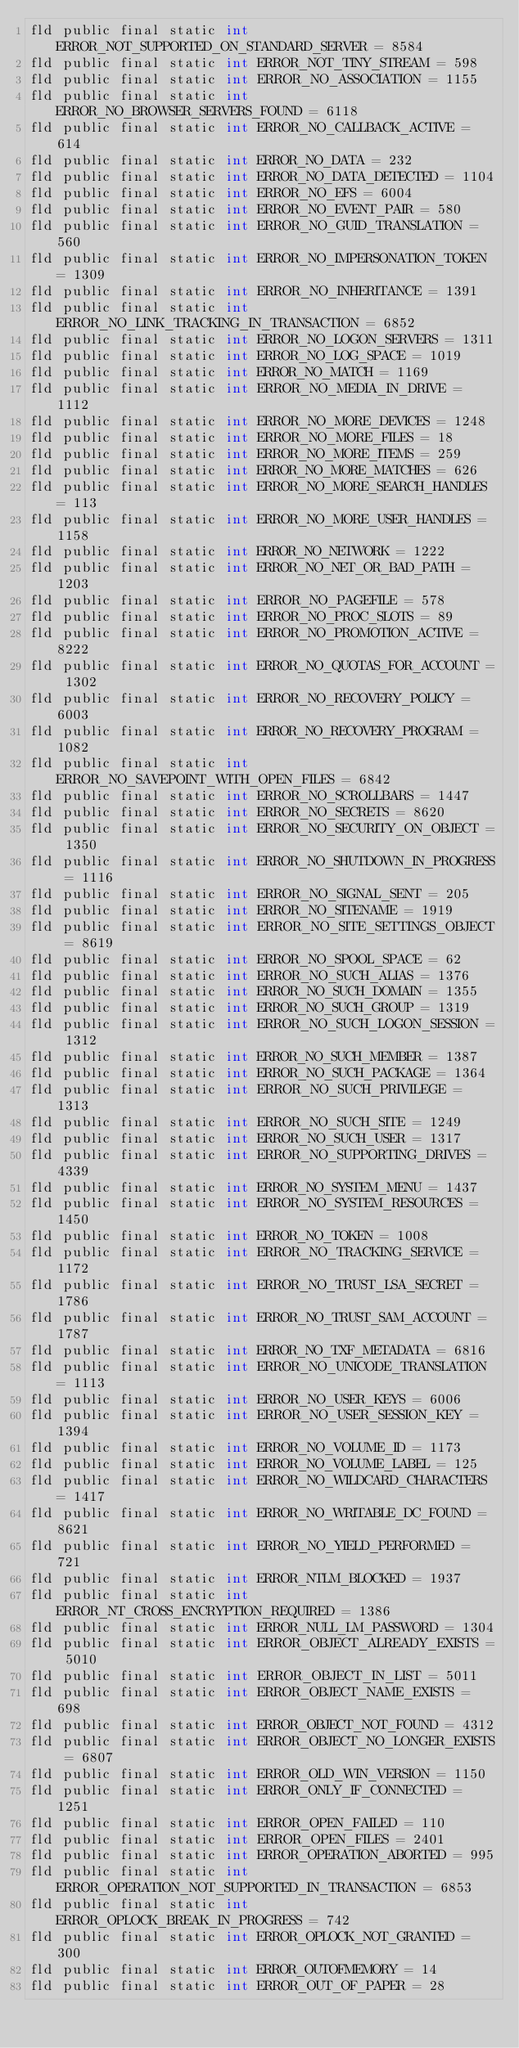Convert code to text. <code><loc_0><loc_0><loc_500><loc_500><_SML_>fld public final static int ERROR_NOT_SUPPORTED_ON_STANDARD_SERVER = 8584
fld public final static int ERROR_NOT_TINY_STREAM = 598
fld public final static int ERROR_NO_ASSOCIATION = 1155
fld public final static int ERROR_NO_BROWSER_SERVERS_FOUND = 6118
fld public final static int ERROR_NO_CALLBACK_ACTIVE = 614
fld public final static int ERROR_NO_DATA = 232
fld public final static int ERROR_NO_DATA_DETECTED = 1104
fld public final static int ERROR_NO_EFS = 6004
fld public final static int ERROR_NO_EVENT_PAIR = 580
fld public final static int ERROR_NO_GUID_TRANSLATION = 560
fld public final static int ERROR_NO_IMPERSONATION_TOKEN = 1309
fld public final static int ERROR_NO_INHERITANCE = 1391
fld public final static int ERROR_NO_LINK_TRACKING_IN_TRANSACTION = 6852
fld public final static int ERROR_NO_LOGON_SERVERS = 1311
fld public final static int ERROR_NO_LOG_SPACE = 1019
fld public final static int ERROR_NO_MATCH = 1169
fld public final static int ERROR_NO_MEDIA_IN_DRIVE = 1112
fld public final static int ERROR_NO_MORE_DEVICES = 1248
fld public final static int ERROR_NO_MORE_FILES = 18
fld public final static int ERROR_NO_MORE_ITEMS = 259
fld public final static int ERROR_NO_MORE_MATCHES = 626
fld public final static int ERROR_NO_MORE_SEARCH_HANDLES = 113
fld public final static int ERROR_NO_MORE_USER_HANDLES = 1158
fld public final static int ERROR_NO_NETWORK = 1222
fld public final static int ERROR_NO_NET_OR_BAD_PATH = 1203
fld public final static int ERROR_NO_PAGEFILE = 578
fld public final static int ERROR_NO_PROC_SLOTS = 89
fld public final static int ERROR_NO_PROMOTION_ACTIVE = 8222
fld public final static int ERROR_NO_QUOTAS_FOR_ACCOUNT = 1302
fld public final static int ERROR_NO_RECOVERY_POLICY = 6003
fld public final static int ERROR_NO_RECOVERY_PROGRAM = 1082
fld public final static int ERROR_NO_SAVEPOINT_WITH_OPEN_FILES = 6842
fld public final static int ERROR_NO_SCROLLBARS = 1447
fld public final static int ERROR_NO_SECRETS = 8620
fld public final static int ERROR_NO_SECURITY_ON_OBJECT = 1350
fld public final static int ERROR_NO_SHUTDOWN_IN_PROGRESS = 1116
fld public final static int ERROR_NO_SIGNAL_SENT = 205
fld public final static int ERROR_NO_SITENAME = 1919
fld public final static int ERROR_NO_SITE_SETTINGS_OBJECT = 8619
fld public final static int ERROR_NO_SPOOL_SPACE = 62
fld public final static int ERROR_NO_SUCH_ALIAS = 1376
fld public final static int ERROR_NO_SUCH_DOMAIN = 1355
fld public final static int ERROR_NO_SUCH_GROUP = 1319
fld public final static int ERROR_NO_SUCH_LOGON_SESSION = 1312
fld public final static int ERROR_NO_SUCH_MEMBER = 1387
fld public final static int ERROR_NO_SUCH_PACKAGE = 1364
fld public final static int ERROR_NO_SUCH_PRIVILEGE = 1313
fld public final static int ERROR_NO_SUCH_SITE = 1249
fld public final static int ERROR_NO_SUCH_USER = 1317
fld public final static int ERROR_NO_SUPPORTING_DRIVES = 4339
fld public final static int ERROR_NO_SYSTEM_MENU = 1437
fld public final static int ERROR_NO_SYSTEM_RESOURCES = 1450
fld public final static int ERROR_NO_TOKEN = 1008
fld public final static int ERROR_NO_TRACKING_SERVICE = 1172
fld public final static int ERROR_NO_TRUST_LSA_SECRET = 1786
fld public final static int ERROR_NO_TRUST_SAM_ACCOUNT = 1787
fld public final static int ERROR_NO_TXF_METADATA = 6816
fld public final static int ERROR_NO_UNICODE_TRANSLATION = 1113
fld public final static int ERROR_NO_USER_KEYS = 6006
fld public final static int ERROR_NO_USER_SESSION_KEY = 1394
fld public final static int ERROR_NO_VOLUME_ID = 1173
fld public final static int ERROR_NO_VOLUME_LABEL = 125
fld public final static int ERROR_NO_WILDCARD_CHARACTERS = 1417
fld public final static int ERROR_NO_WRITABLE_DC_FOUND = 8621
fld public final static int ERROR_NO_YIELD_PERFORMED = 721
fld public final static int ERROR_NTLM_BLOCKED = 1937
fld public final static int ERROR_NT_CROSS_ENCRYPTION_REQUIRED = 1386
fld public final static int ERROR_NULL_LM_PASSWORD = 1304
fld public final static int ERROR_OBJECT_ALREADY_EXISTS = 5010
fld public final static int ERROR_OBJECT_IN_LIST = 5011
fld public final static int ERROR_OBJECT_NAME_EXISTS = 698
fld public final static int ERROR_OBJECT_NOT_FOUND = 4312
fld public final static int ERROR_OBJECT_NO_LONGER_EXISTS = 6807
fld public final static int ERROR_OLD_WIN_VERSION = 1150
fld public final static int ERROR_ONLY_IF_CONNECTED = 1251
fld public final static int ERROR_OPEN_FAILED = 110
fld public final static int ERROR_OPEN_FILES = 2401
fld public final static int ERROR_OPERATION_ABORTED = 995
fld public final static int ERROR_OPERATION_NOT_SUPPORTED_IN_TRANSACTION = 6853
fld public final static int ERROR_OPLOCK_BREAK_IN_PROGRESS = 742
fld public final static int ERROR_OPLOCK_NOT_GRANTED = 300
fld public final static int ERROR_OUTOFMEMORY = 14
fld public final static int ERROR_OUT_OF_PAPER = 28</code> 